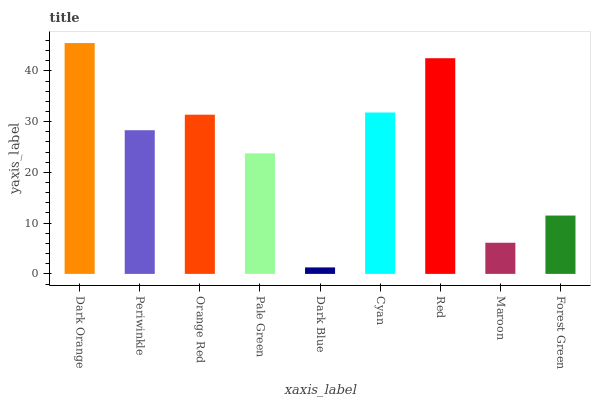Is Dark Blue the minimum?
Answer yes or no. Yes. Is Dark Orange the maximum?
Answer yes or no. Yes. Is Periwinkle the minimum?
Answer yes or no. No. Is Periwinkle the maximum?
Answer yes or no. No. Is Dark Orange greater than Periwinkle?
Answer yes or no. Yes. Is Periwinkle less than Dark Orange?
Answer yes or no. Yes. Is Periwinkle greater than Dark Orange?
Answer yes or no. No. Is Dark Orange less than Periwinkle?
Answer yes or no. No. Is Periwinkle the high median?
Answer yes or no. Yes. Is Periwinkle the low median?
Answer yes or no. Yes. Is Forest Green the high median?
Answer yes or no. No. Is Orange Red the low median?
Answer yes or no. No. 